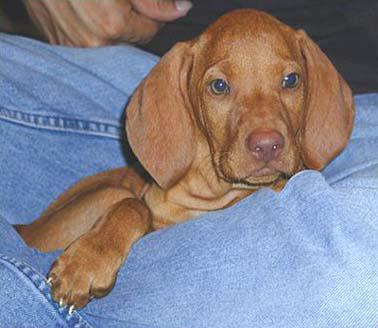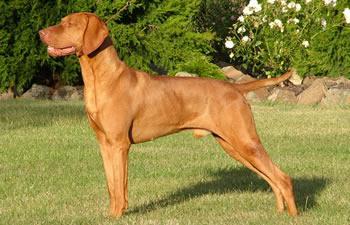The first image is the image on the left, the second image is the image on the right. Considering the images on both sides, is "At least one image shows one red-orange dog standing with head and body in profile turned leftward, and tail extended." valid? Answer yes or no. Yes. The first image is the image on the left, the second image is the image on the right. For the images shown, is this caption "A brown dog stand straight looking to the left while on the grass." true? Answer yes or no. Yes. 